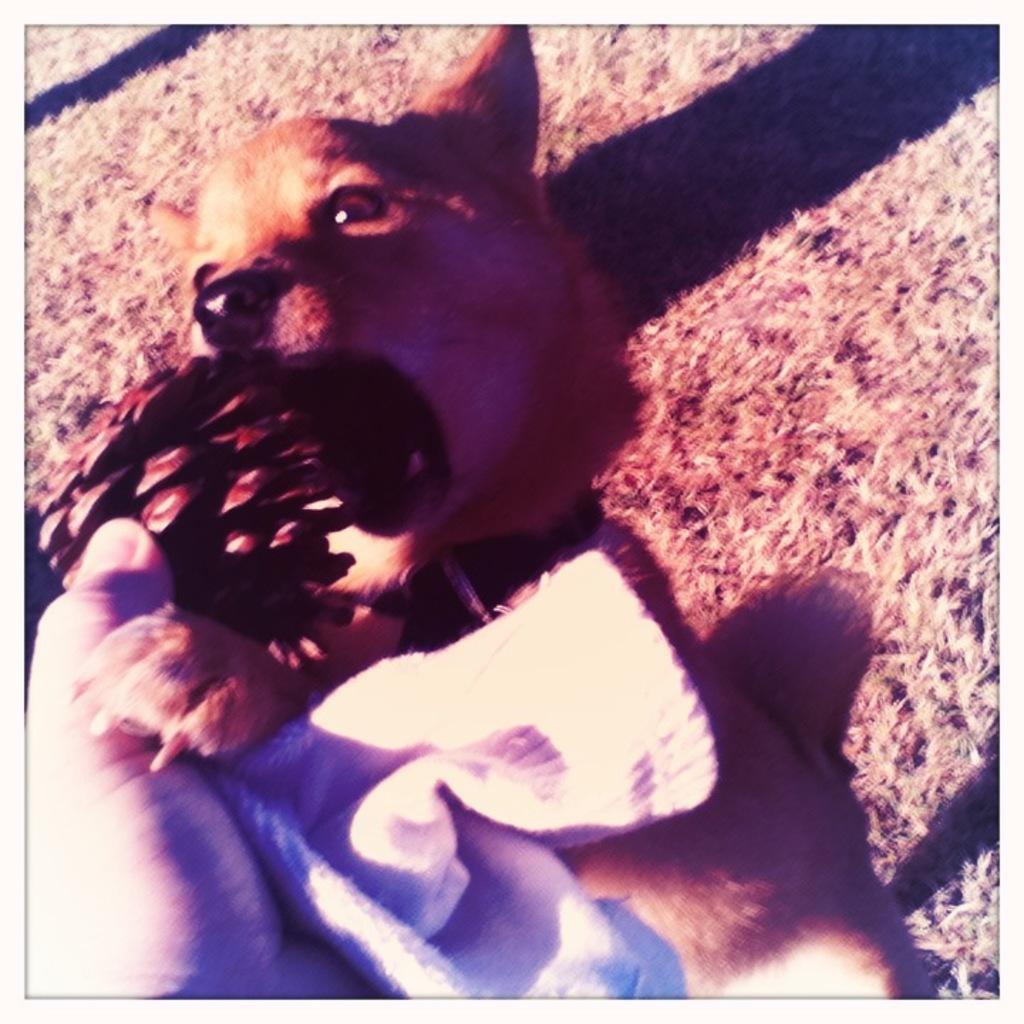How would you summarize this image in a sentence or two? In this image I can see a hand of a person is holding a cloth. I can also see a brown colour dog over here. 